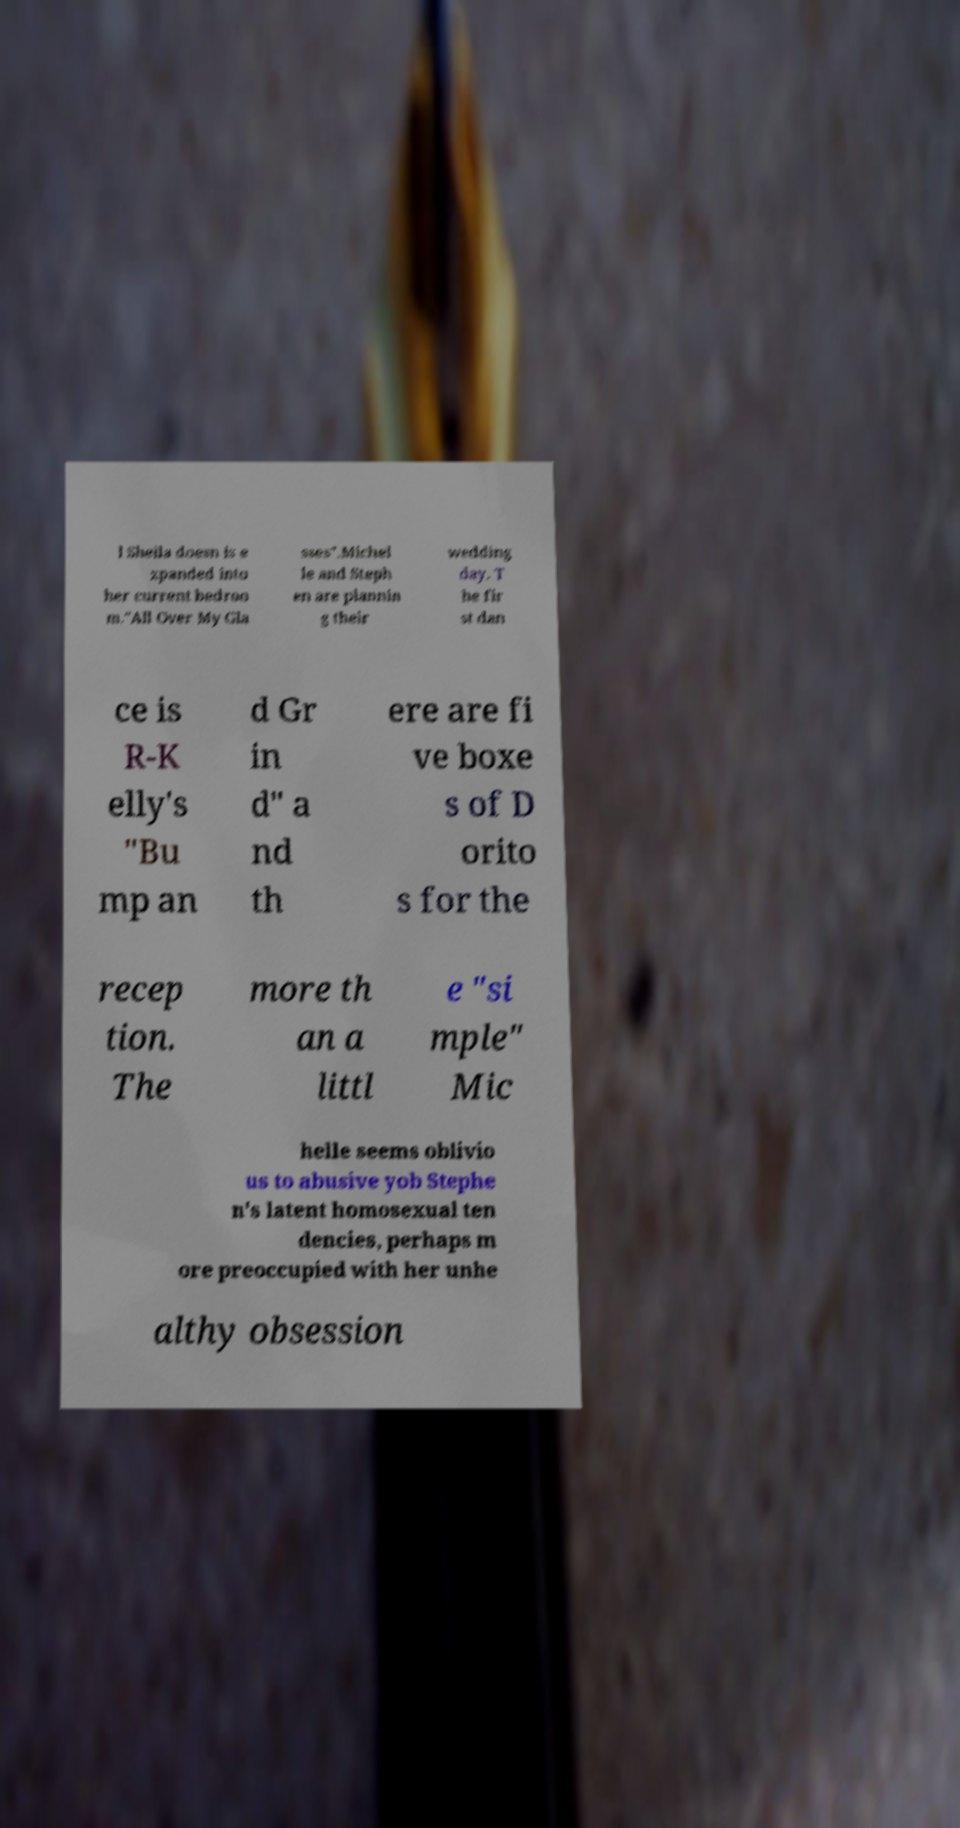Can you accurately transcribe the text from the provided image for me? l Sheila doesn is e xpanded into her current bedroo m."All Over My Gla sses".Michel le and Steph en are plannin g their wedding day. T he fir st dan ce is R-K elly's "Bu mp an d Gr in d" a nd th ere are fi ve boxe s of D orito s for the recep tion. The more th an a littl e "si mple" Mic helle seems oblivio us to abusive yob Stephe n's latent homosexual ten dencies, perhaps m ore preoccupied with her unhe althy obsession 